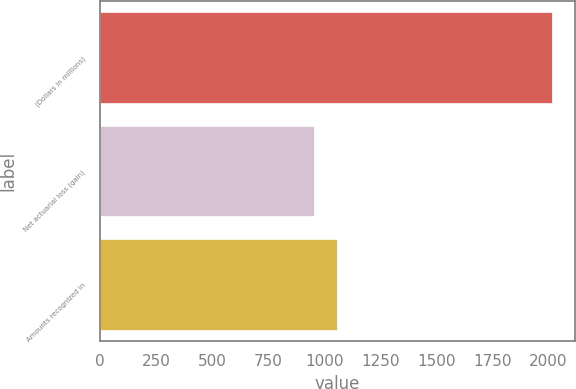Convert chart. <chart><loc_0><loc_0><loc_500><loc_500><bar_chart><fcel>(Dollars in millions)<fcel>Net actuarial loss (gain)<fcel>Amounts recognized in<nl><fcel>2016<fcel>953<fcel>1059.3<nl></chart> 